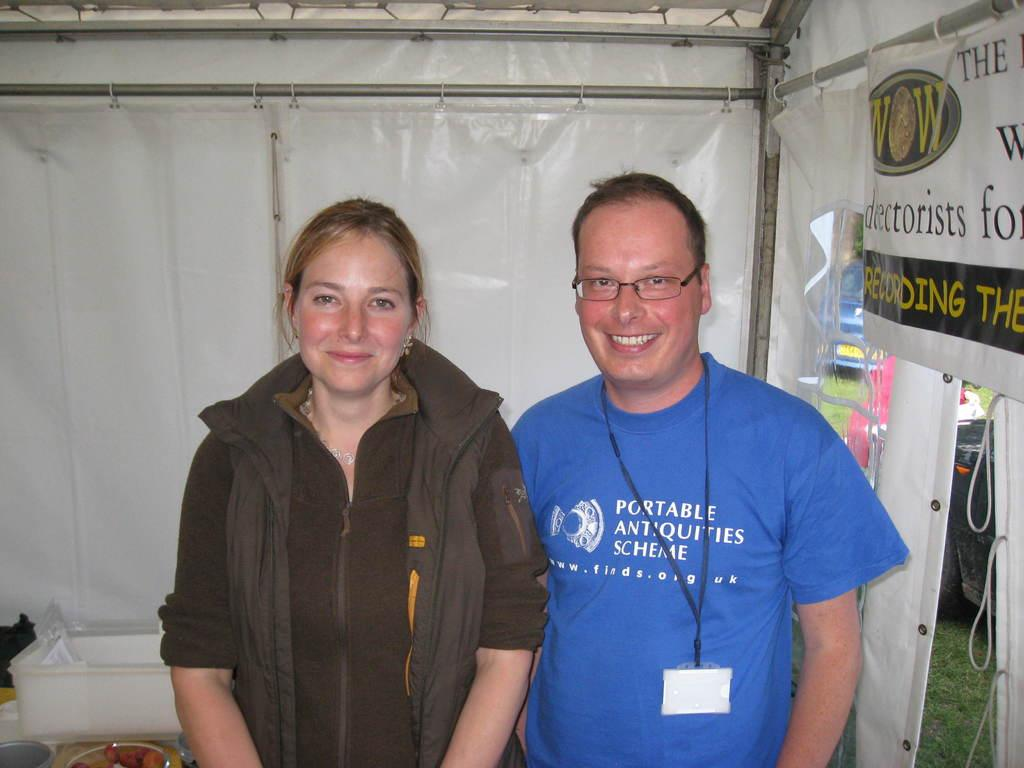How many people are present in the image? There is a lady and a man in the image. What can be seen on the wall in the image? There is a poster with text in the image. What type of shelter is visible in the image? There is a tent in the image. What type of ground surface is present in the image? There is grass in the image. What type of food is on the plate in the image? There are food items on a plate in the image. What object in the image might be used for storage? There is a box in the image. What type of lamp is hanging from the tent in the image? There is no lamp present in the image, and the tent does not have any hanging objects. 